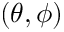Convert formula to latex. <formula><loc_0><loc_0><loc_500><loc_500>( \theta , \phi )</formula> 